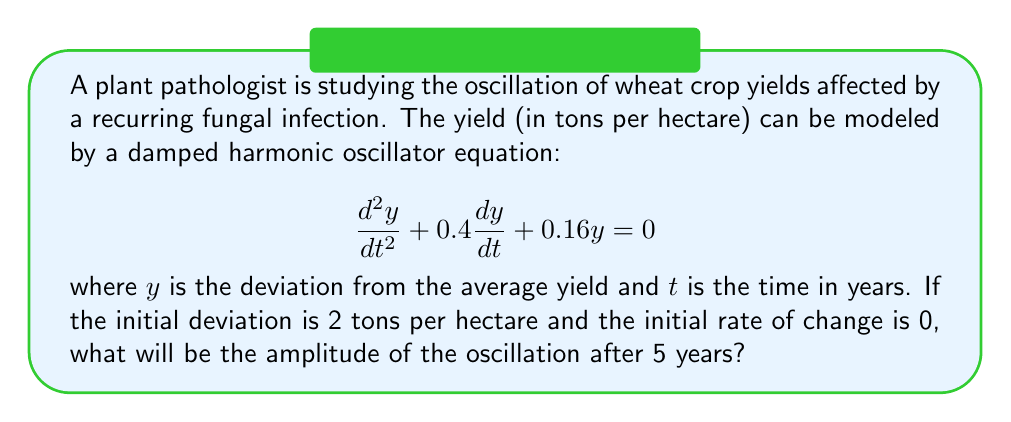Provide a solution to this math problem. To solve this problem, we need to follow these steps:

1) The general form of a damped harmonic oscillator equation is:
   $$\frac{d^2y}{dt^2} + 2\beta\frac{dy}{dt} + \omega_0^2y = 0$$
   
   Comparing this with our equation, we see that $2\beta = 0.4$ and $\omega_0^2 = 0.16$.

2) Calculate $\beta$ and $\omega_0$:
   $\beta = 0.2$ and $\omega_0 = 0.4$

3) Calculate the damped frequency $\omega$:
   $$\omega = \sqrt{\omega_0^2 - \beta^2} = \sqrt{0.4^2 - 0.2^2} = \sqrt{0.12} \approx 0.3464$$

4) The general solution for underdamped oscillation ($\beta < \omega_0$) is:
   $$y(t) = Ae^{-\beta t}\cos(\omega t + \phi)$$
   where $A$ is the initial amplitude and $\phi$ is the phase shift.

5) Given the initial conditions $y(0) = 2$ and $y'(0) = 0$, we can determine that $A = 2$ and $\phi = 0$.

6) Therefore, our specific solution is:
   $$y(t) = 2e^{-0.2t}\cos(0.3464t)$$

7) The amplitude after 5 years will be:
   $$A(5) = 2e^{-0.2(5)} = 2e^{-1} \approx 0.7358$$

Thus, the amplitude of the oscillation after 5 years will be approximately 0.7358 tons per hectare.
Answer: 0.7358 tons per hectare 